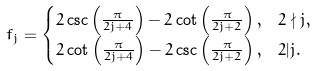<formula> <loc_0><loc_0><loc_500><loc_500>f _ { j } & = \begin{cases} 2 \csc \left ( \frac { \pi } { 2 j + 4 } \right ) - 2 \cot \left ( \frac { \pi } { 2 j + 2 } \right ) , & 2 \nmid j , \\ 2 \cot \left ( \frac { \pi } { 2 j + 4 } \right ) - 2 \csc \left ( \frac { \pi } { 2 j + 2 } \right ) , & 2 | j . \end{cases}</formula> 